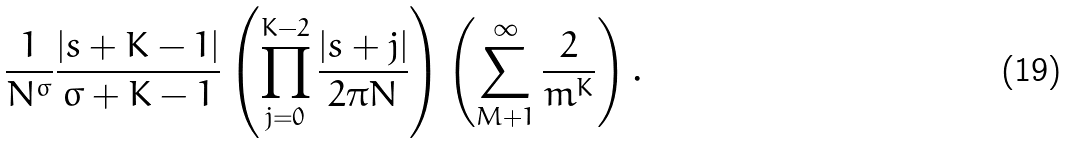<formula> <loc_0><loc_0><loc_500><loc_500>\frac { 1 } { N ^ { \sigma } } \frac { | s + K - 1 | } { \sigma + K - 1 } \left ( \prod _ { j = 0 } ^ { K - 2 } \frac { | s + j | } { 2 \pi N } \right ) \left ( \sum _ { M + 1 } ^ { \infty } \frac { 2 } { m ^ { K } } \right ) .</formula> 